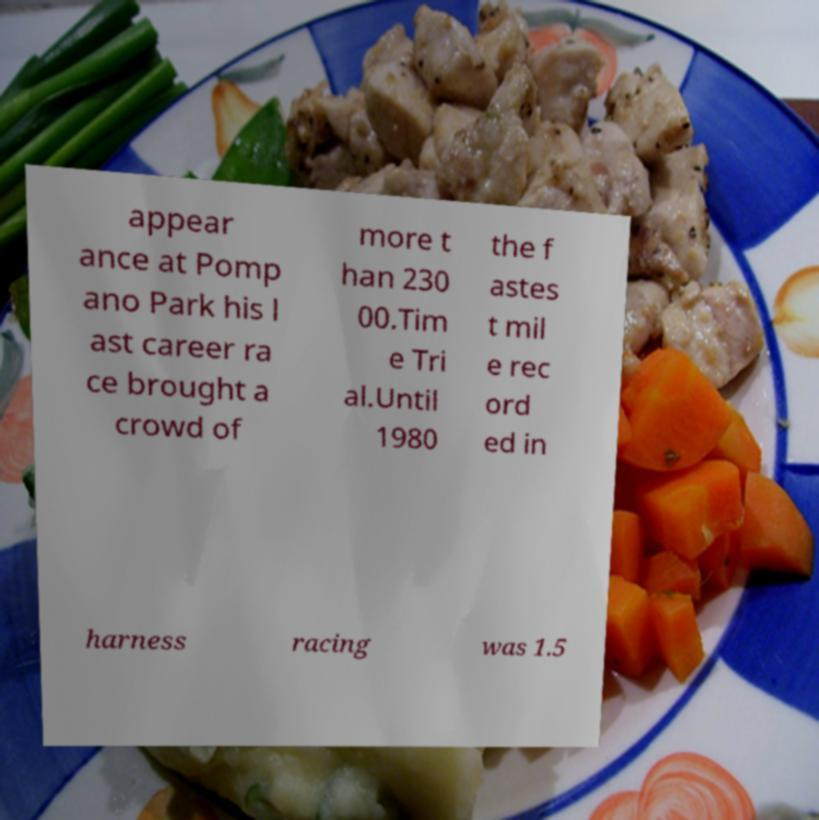Can you accurately transcribe the text from the provided image for me? appear ance at Pomp ano Park his l ast career ra ce brought a crowd of more t han 230 00.Tim e Tri al.Until 1980 the f astes t mil e rec ord ed in harness racing was 1.5 